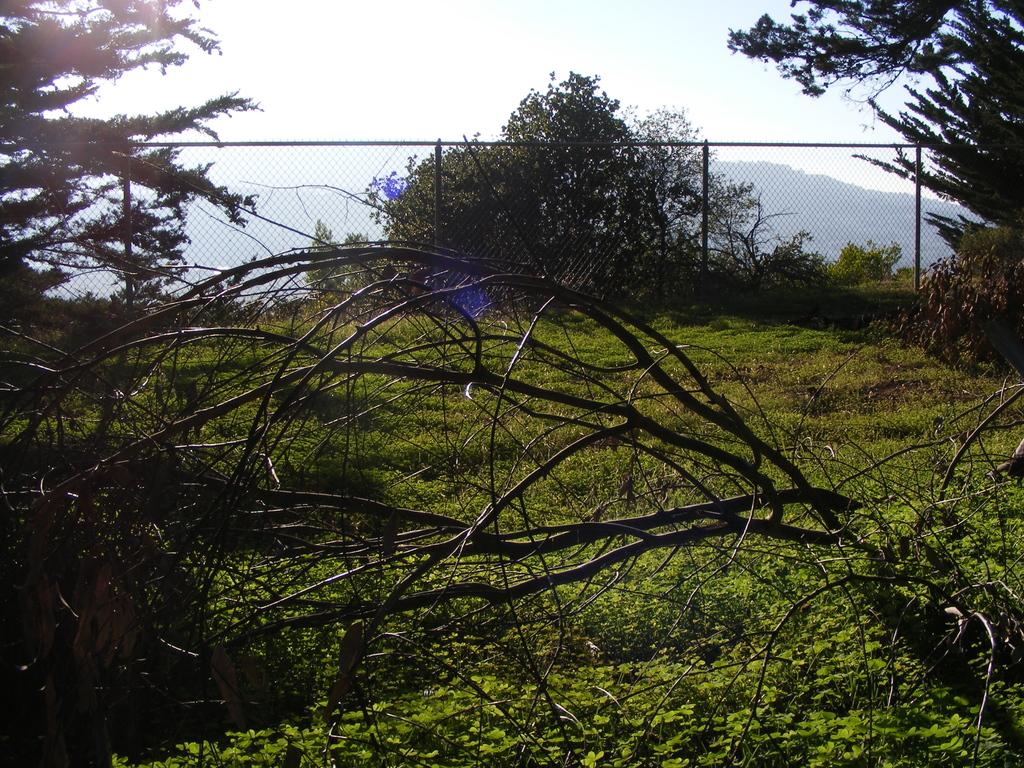What type of vegetation can be seen in the image? There are plants, grass, and trees in the image. What type of barrier is present in the image? There is a fence in the image. What is the terrain like in the image? There is a hill in the image. What can be seen in the background of the image? The sky is visible in the background of the image. How many hands are visible in the image? There are no hands visible in the image. What type of comfort can be found in the image? The image does not depict any objects or situations that would provide comfort. 